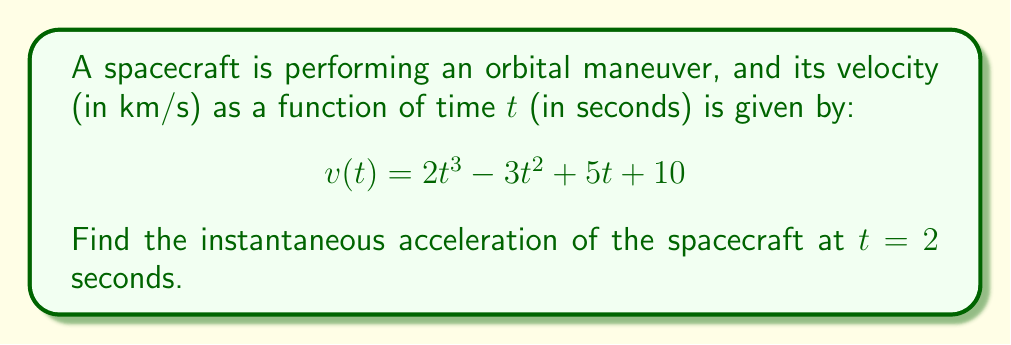Provide a solution to this math problem. To find the instantaneous acceleration, we need to follow these steps:

1) Recall that acceleration is the derivative of velocity with respect to time.

2) Given velocity function:
   $$v(t) = 2t^3 - 3t^2 + 5t + 10$$

3) To find acceleration, we need to differentiate v(t):
   $$a(t) = \frac{d}{dt}v(t) = \frac{d}{dt}(2t^3 - 3t^2 + 5t + 10)$$

4) Using the power rule and constant rule of differentiation:
   $$a(t) = 6t^2 - 6t + 5$$

5) Now, we need to find a(2), the acceleration at t = 2 seconds:
   $$a(2) = 6(2)^2 - 6(2) + 5$$

6) Simplify:
   $$a(2) = 6(4) - 12 + 5 = 24 - 12 + 5 = 17$$

Therefore, the instantaneous acceleration of the spacecraft at t = 2 seconds is 17 km/s².
Answer: 17 km/s² 